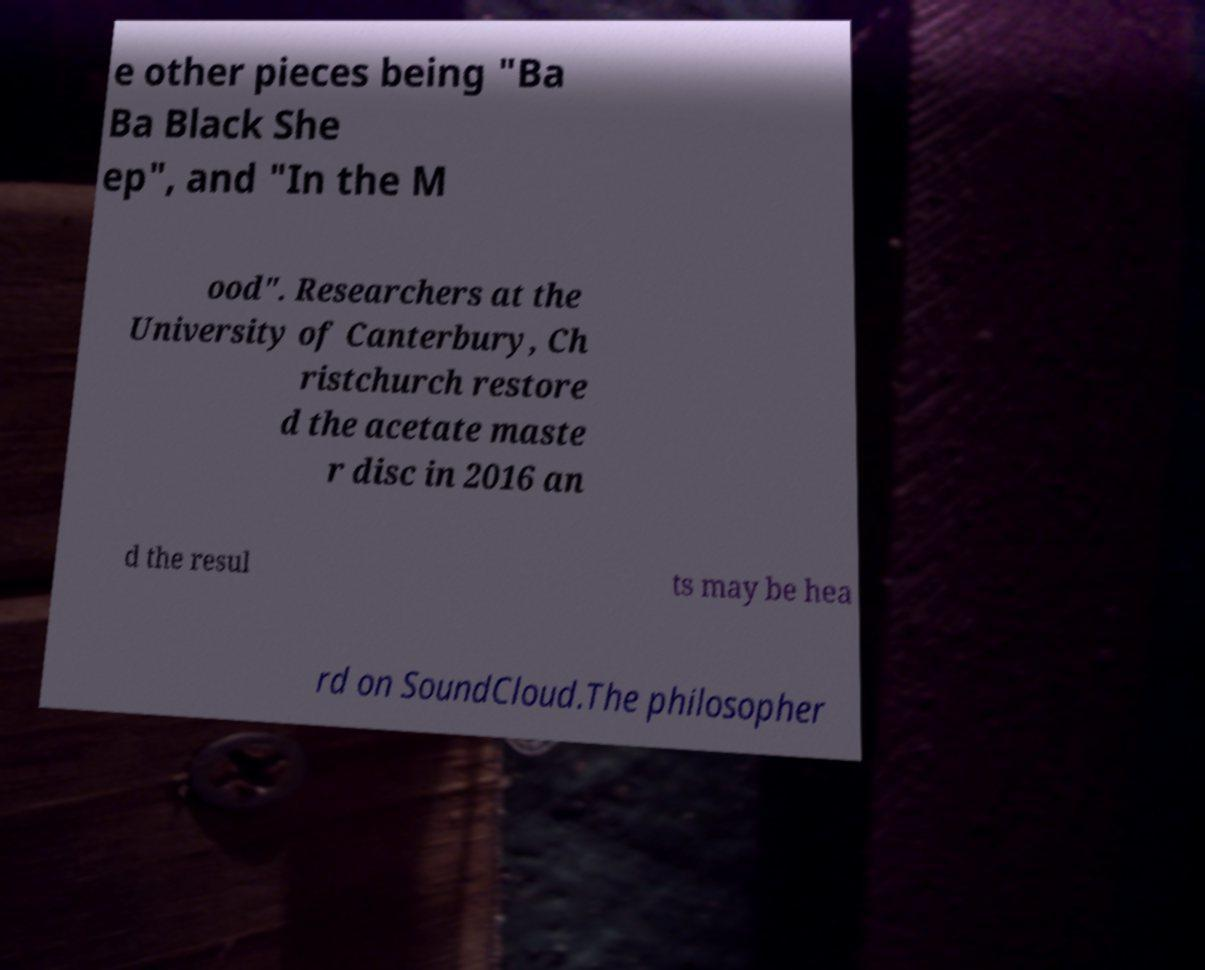There's text embedded in this image that I need extracted. Can you transcribe it verbatim? e other pieces being "Ba Ba Black She ep", and "In the M ood". Researchers at the University of Canterbury, Ch ristchurch restore d the acetate maste r disc in 2016 an d the resul ts may be hea rd on SoundCloud.The philosopher 